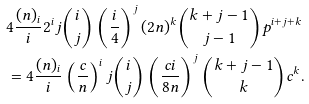Convert formula to latex. <formula><loc_0><loc_0><loc_500><loc_500>& 4 \frac { ( n ) _ { i } } { i } 2 ^ { i } j \binom { i } { j } \left ( \frac { i } { 4 } \right ) ^ { j } ( 2 n ) ^ { k } \binom { k + j - 1 } { j - 1 } p ^ { i + j + k } \\ & = 4 \frac { ( n ) _ { i } } { i } \left ( \frac { c } { n } \right ) ^ { i } j \binom { i } { j } \left ( \frac { c i } { 8 n } \right ) ^ { j } \binom { k + j - 1 } { k } c ^ { k } .</formula> 